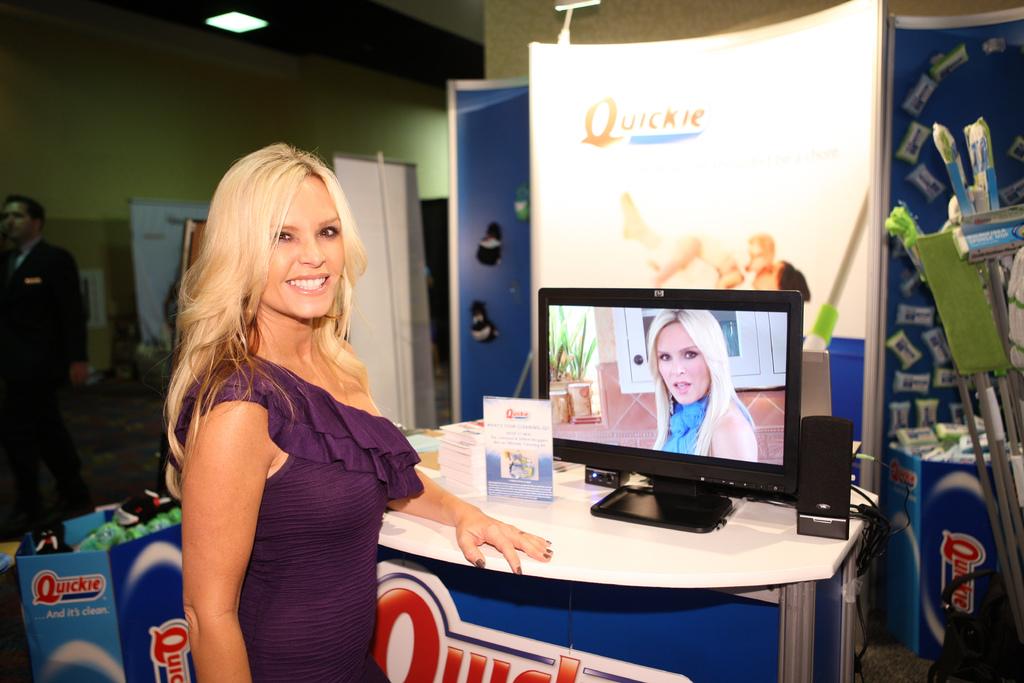What brand is the model representing?
Provide a succinct answer. Quickie. What's the brand's slogan?
Offer a terse response. And its clean. 